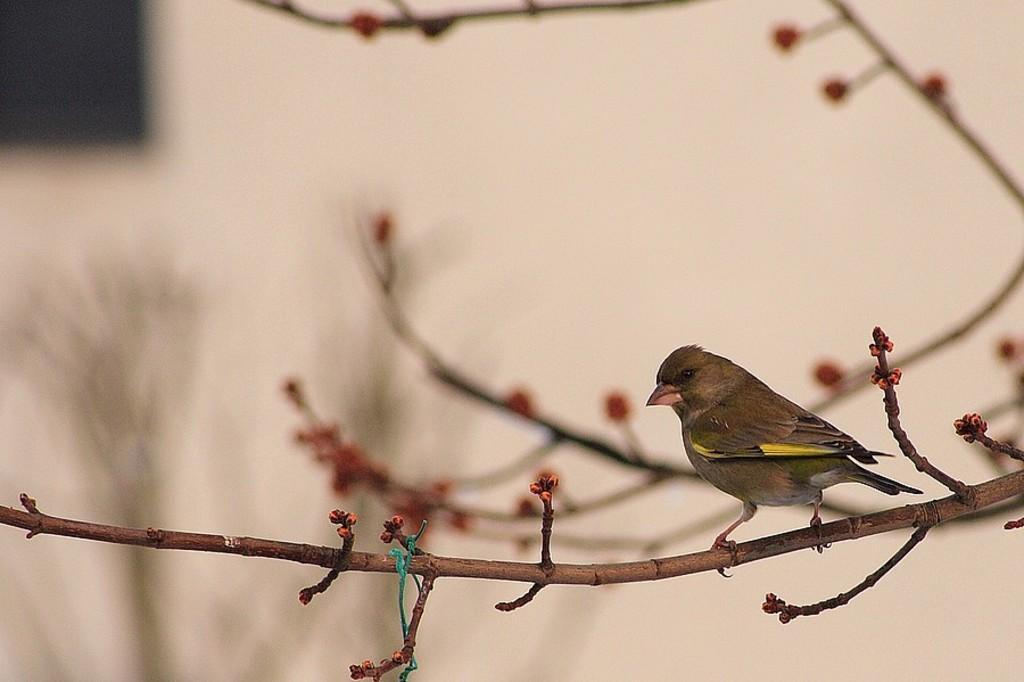Describe this image in one or two sentences. This picture seems to be clicked inside. On the right we can see a bird standing on the stem of a tree and we can see the stems and flowers. In the background there is an object which seems to be the wall and we can see some other objects in the background. 